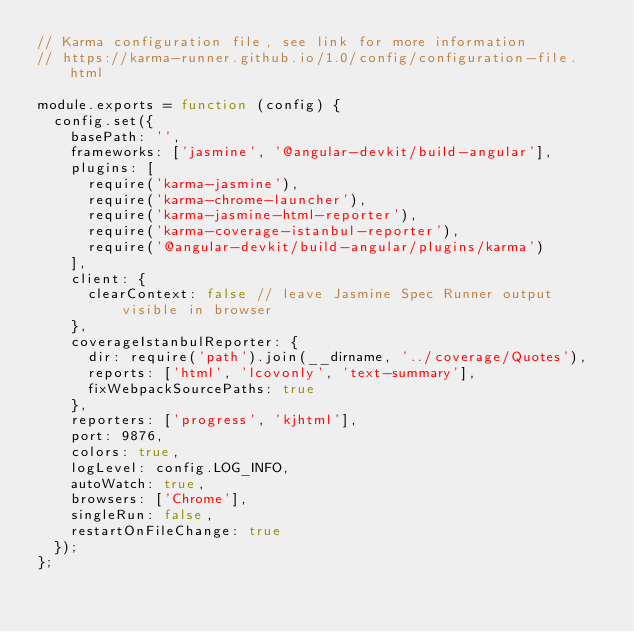Convert code to text. <code><loc_0><loc_0><loc_500><loc_500><_JavaScript_>// Karma configuration file, see link for more information
// https://karma-runner.github.io/1.0/config/configuration-file.html

module.exports = function (config) {
  config.set({
    basePath: '',
    frameworks: ['jasmine', '@angular-devkit/build-angular'],
    plugins: [
      require('karma-jasmine'),
      require('karma-chrome-launcher'),
      require('karma-jasmine-html-reporter'),
      require('karma-coverage-istanbul-reporter'),
      require('@angular-devkit/build-angular/plugins/karma')
    ],
    client: {
      clearContext: false // leave Jasmine Spec Runner output visible in browser
    },
    coverageIstanbulReporter: {
      dir: require('path').join(__dirname, '../coverage/Quotes'),
      reports: ['html', 'lcovonly', 'text-summary'],
      fixWebpackSourcePaths: true
    },
    reporters: ['progress', 'kjhtml'],
    port: 9876,
    colors: true,
    logLevel: config.LOG_INFO,
    autoWatch: true,
    browsers: ['Chrome'],
    singleRun: false,
    restartOnFileChange: true
  });
};
</code> 